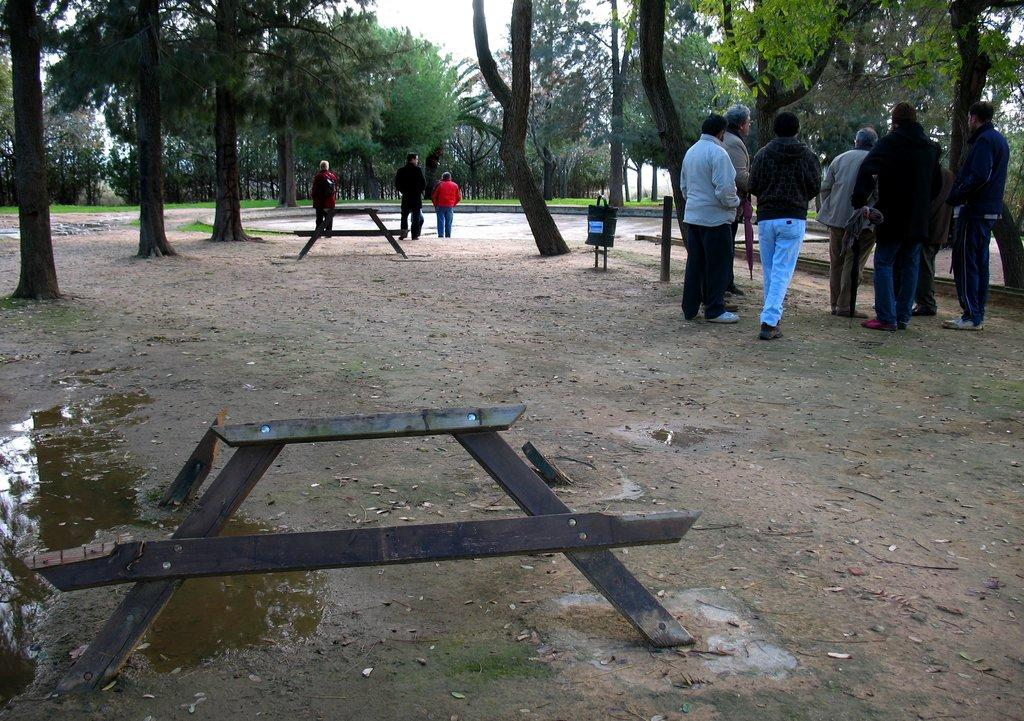What are the people in the image doing? The people in the image are standing and walking. What type of terrain can be seen in the image? The land is visible in the image. What kind of vegetation is present in the image? Trees are present around the place in the image. What is visible in the background of the image? The sky is visible in the image. What is the condition of the wooden furniture in the image? There is a broken wooden furniture in the front of the image. How many ducks are swimming in the water in the image? There is no water or ducks present in the image. What are the people using to hold the hands of others in the image? There is no mention of people holding hands in the image. 